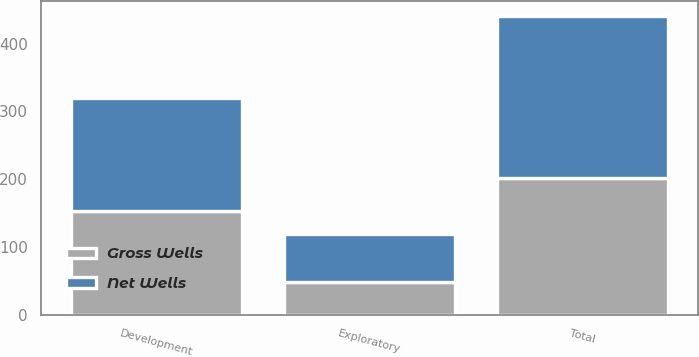Convert chart. <chart><loc_0><loc_0><loc_500><loc_500><stacked_bar_chart><ecel><fcel>Development<fcel>Exploratory<fcel>Total<nl><fcel>Net Wells<fcel>167<fcel>71<fcel>238<nl><fcel>Gross Wells<fcel>153<fcel>49<fcel>202<nl></chart> 